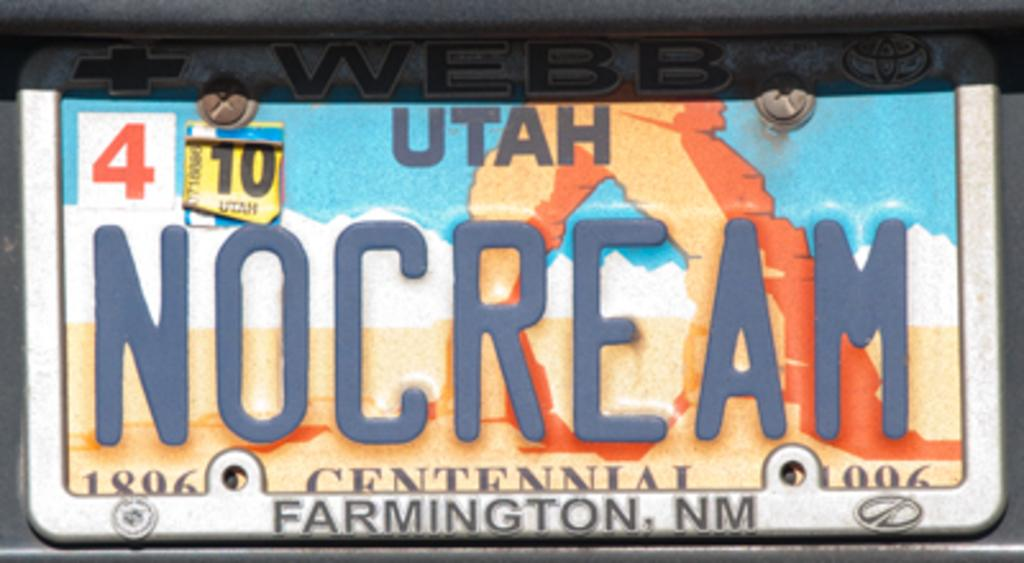What object is present in the image that might hold food? There is a plate in the image. What is written or depicted on the plate? The plate contains text, numbers, and an image. Can you describe the text on the plate? Unfortunately, the specific text on the plate cannot be determined from the provided facts. Where is the baby playing in the image? There is no baby present in the image; it only features a plate with text, numbers, and an image. 